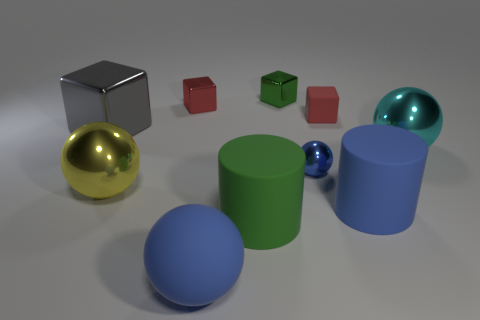There is another block that is the same color as the rubber cube; what is it made of?
Your answer should be very brief. Metal. What is the color of the small sphere?
Make the answer very short. Blue. What is the color of the large metallic object to the right of the matte cylinder that is to the right of the big green rubber object?
Ensure brevity in your answer.  Cyan. There is a small green metallic object that is to the left of the large blue object to the right of the large cylinder on the left side of the small green shiny block; what shape is it?
Keep it short and to the point. Cube. What number of red cubes have the same material as the large cyan ball?
Your answer should be compact. 1. There is a small cube to the right of the tiny blue shiny thing; what number of big blue rubber spheres are in front of it?
Your answer should be compact. 1. How many purple metallic objects are there?
Offer a terse response. 0. Are the big yellow sphere and the large blue object on the right side of the matte block made of the same material?
Give a very brief answer. No. There is a large matte cylinder right of the tiny blue shiny thing; is its color the same as the tiny ball?
Offer a terse response. Yes. There is a thing that is behind the large gray shiny cube and to the left of the green shiny block; what is it made of?
Offer a very short reply. Metal. 